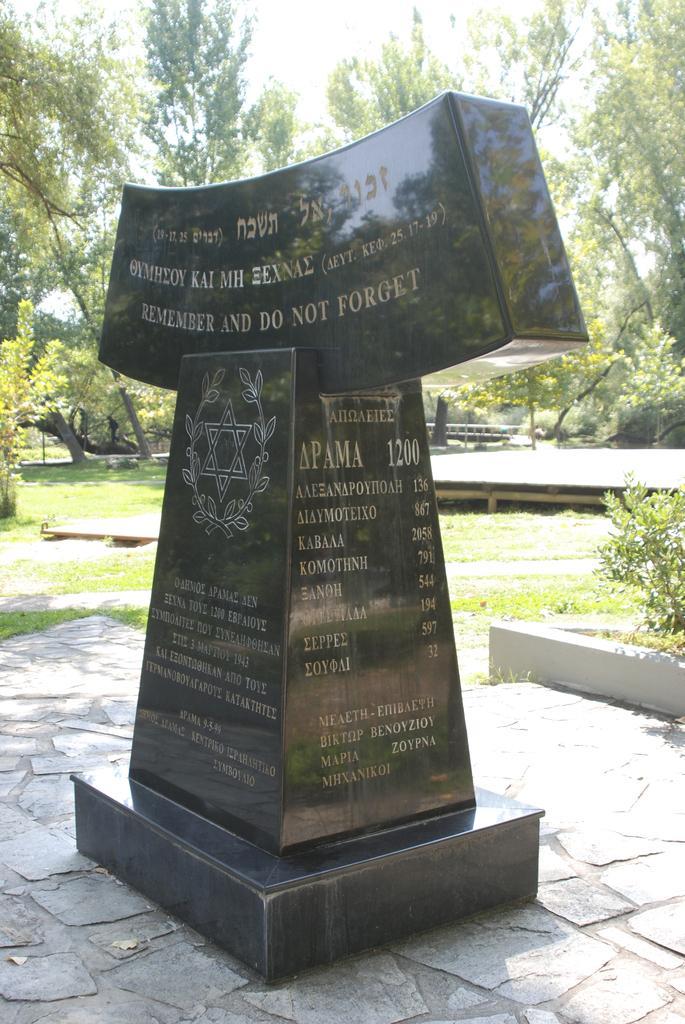Could you give a brief overview of what you see in this image? In this picture there is a memorial in the foreground. There is a text on the memorial. At the back there are trees. At the top there is sky. At the bottom there is grass. 